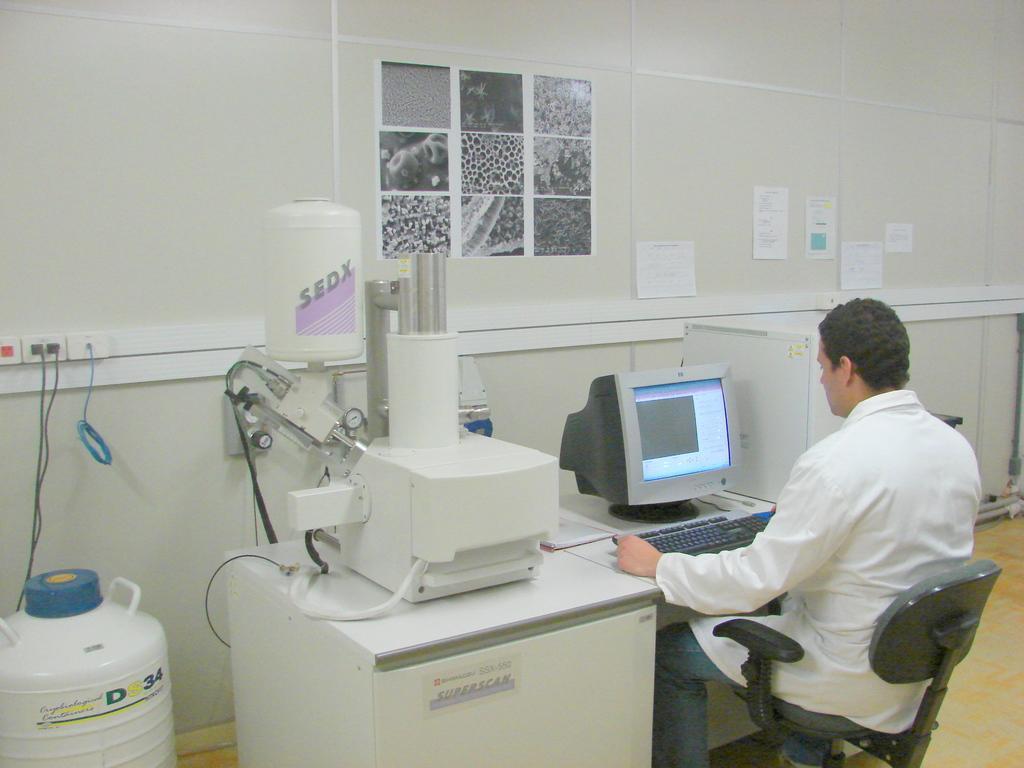Describe this image in one or two sentences. On the right side a person sitting on the chair. In front of him there is a table with keyboard, monitor and a machine. In the back there is a wall with images and notices. On the left side there is a can. On the wall there is a switchboard and there are wires. 